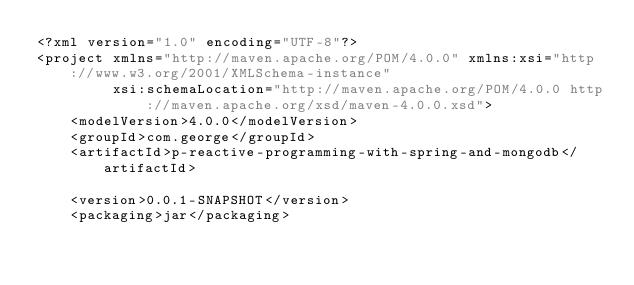<code> <loc_0><loc_0><loc_500><loc_500><_XML_><?xml version="1.0" encoding="UTF-8"?>
<project xmlns="http://maven.apache.org/POM/4.0.0" xmlns:xsi="http://www.w3.org/2001/XMLSchema-instance"
         xsi:schemaLocation="http://maven.apache.org/POM/4.0.0 http://maven.apache.org/xsd/maven-4.0.0.xsd">
    <modelVersion>4.0.0</modelVersion>
    <groupId>com.george</groupId>
    <artifactId>p-reactive-programming-with-spring-and-mongodb</artifactId>

    <version>0.0.1-SNAPSHOT</version>
    <packaging>jar</packaging>
</code> 